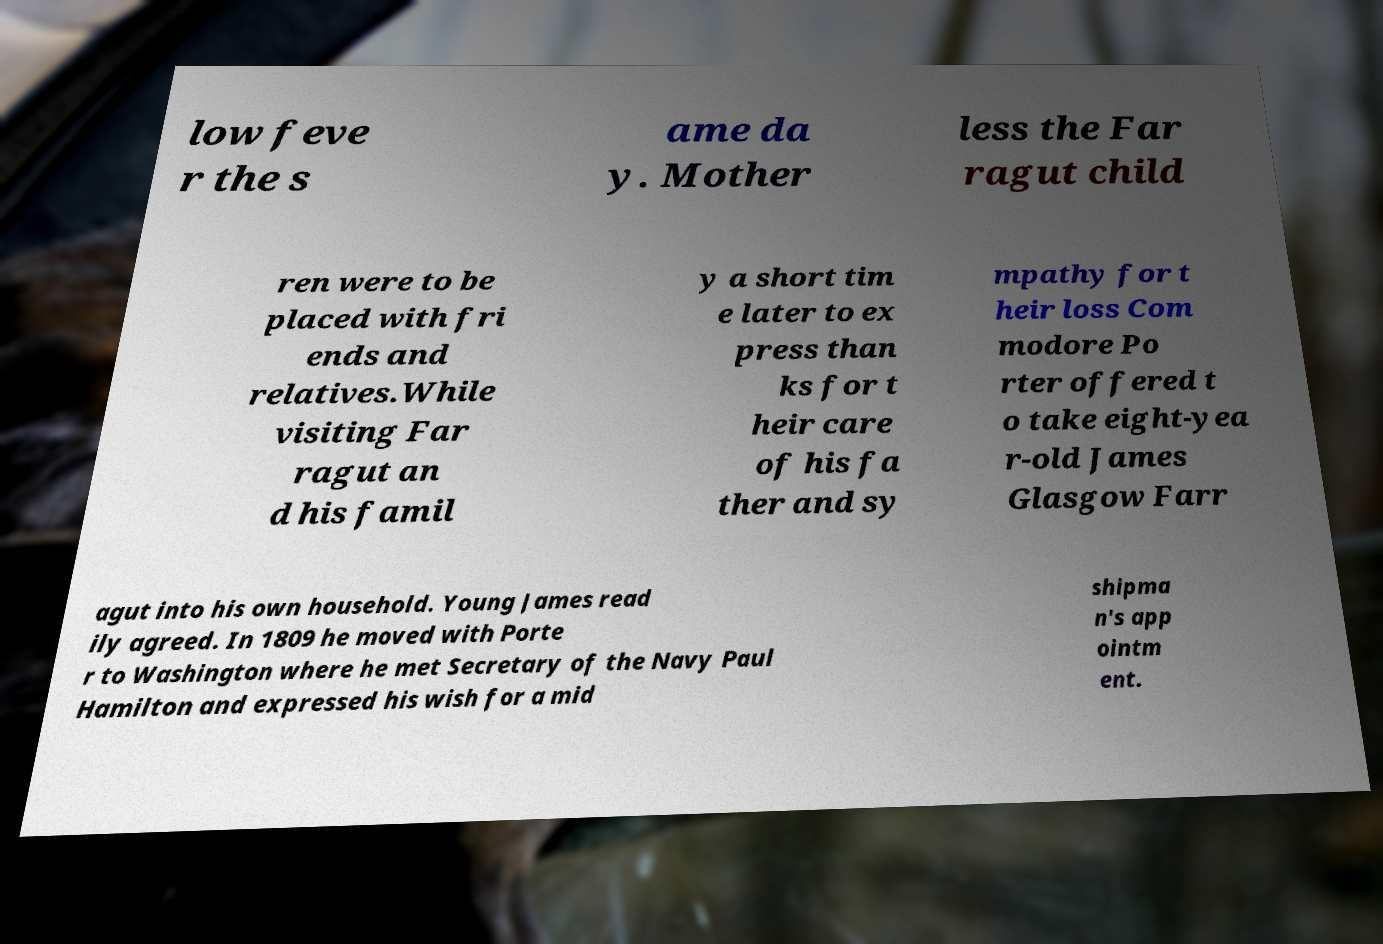Please identify and transcribe the text found in this image. low feve r the s ame da y. Mother less the Far ragut child ren were to be placed with fri ends and relatives.While visiting Far ragut an d his famil y a short tim e later to ex press than ks for t heir care of his fa ther and sy mpathy for t heir loss Com modore Po rter offered t o take eight-yea r-old James Glasgow Farr agut into his own household. Young James read ily agreed. In 1809 he moved with Porte r to Washington where he met Secretary of the Navy Paul Hamilton and expressed his wish for a mid shipma n's app ointm ent. 